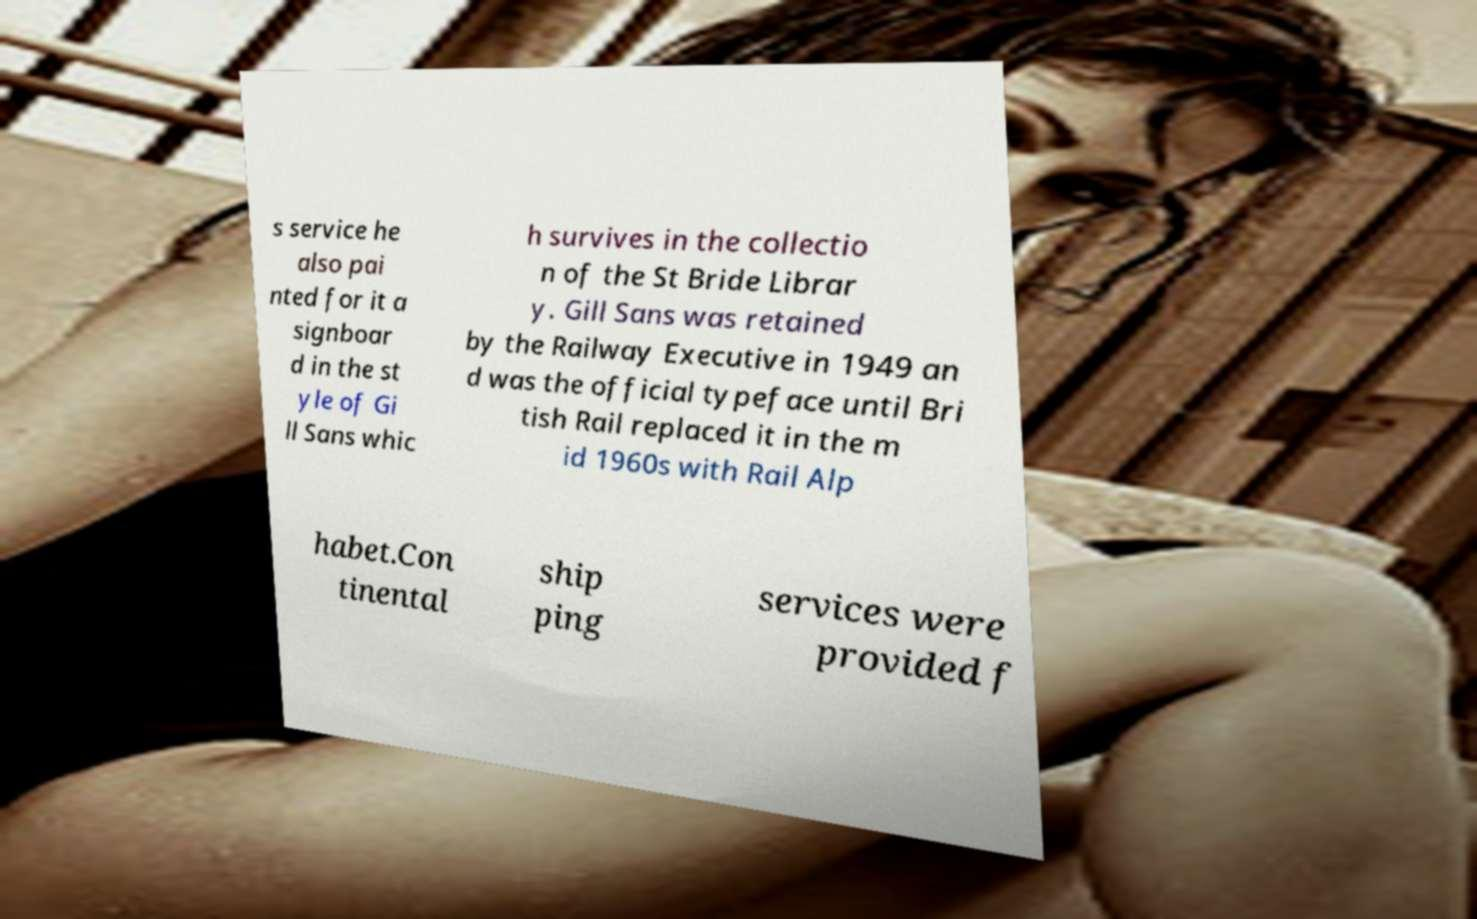Please identify and transcribe the text found in this image. s service he also pai nted for it a signboar d in the st yle of Gi ll Sans whic h survives in the collectio n of the St Bride Librar y. Gill Sans was retained by the Railway Executive in 1949 an d was the official typeface until Bri tish Rail replaced it in the m id 1960s with Rail Alp habet.Con tinental ship ping services were provided f 